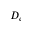Convert formula to latex. <formula><loc_0><loc_0><loc_500><loc_500>D _ { e }</formula> 